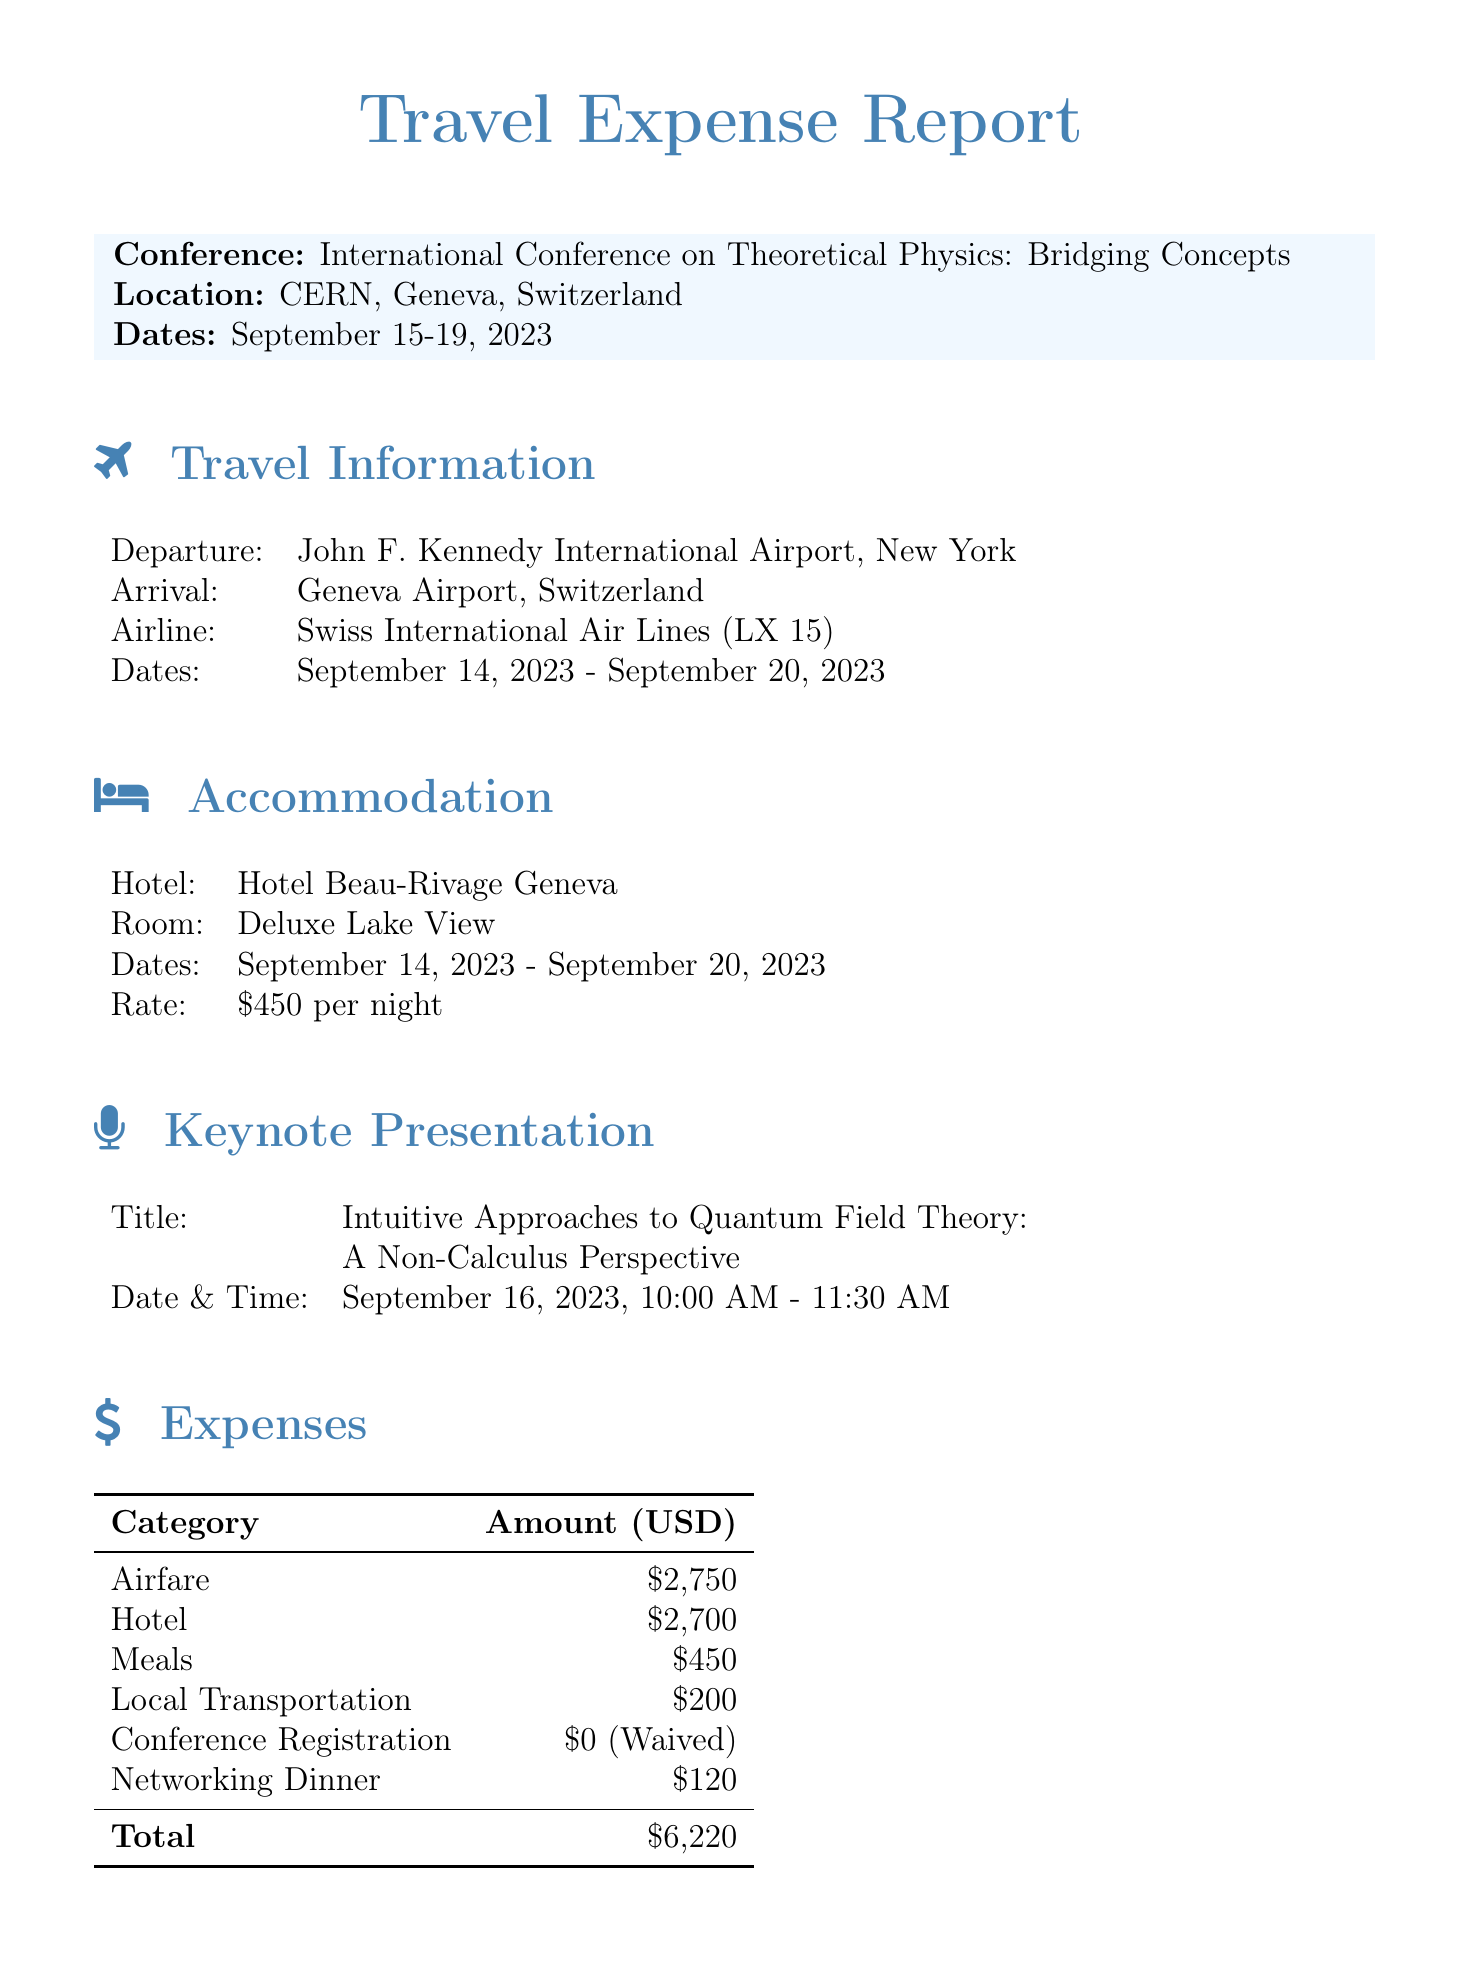What is the name of the conference? The conference name is stated in the document under conference details.
Answer: International Conference on Theoretical Physics: Bridging Concepts What are the dates of the conference? The dates of the conference are mentioned in the conference details section.
Answer: September 15-19, 2023 What was the airfare expense? The airfare expense is given in the expenses section of the report.
Answer: 2750 How many nights did the accommodation span? The check-in and check-out dates indicate the total nights stayed at the hotel.
Answer: 6 nights What is the title of the keynote presentation? The title is provided in the keynote presentation section of the document.
Answer: Intuitive Approaches to Quantum Field Theory: A Non-Calculus Perspective What was the total amount of expenses? The total expenses are computed and listed in the expenses section of the document.
Answer: 6220 Was the conference registration fee waived? The note in the expenses section indicates the status of the registration fee.
Answer: Yes What was the reimbursement deadline? The reimbursement deadline is mentioned in the additional information section.
Answer: October 5, 2023 What payment method was used for the expenses? The payment method is specified in the reimbursement information section.
Answer: University Corporate Card 